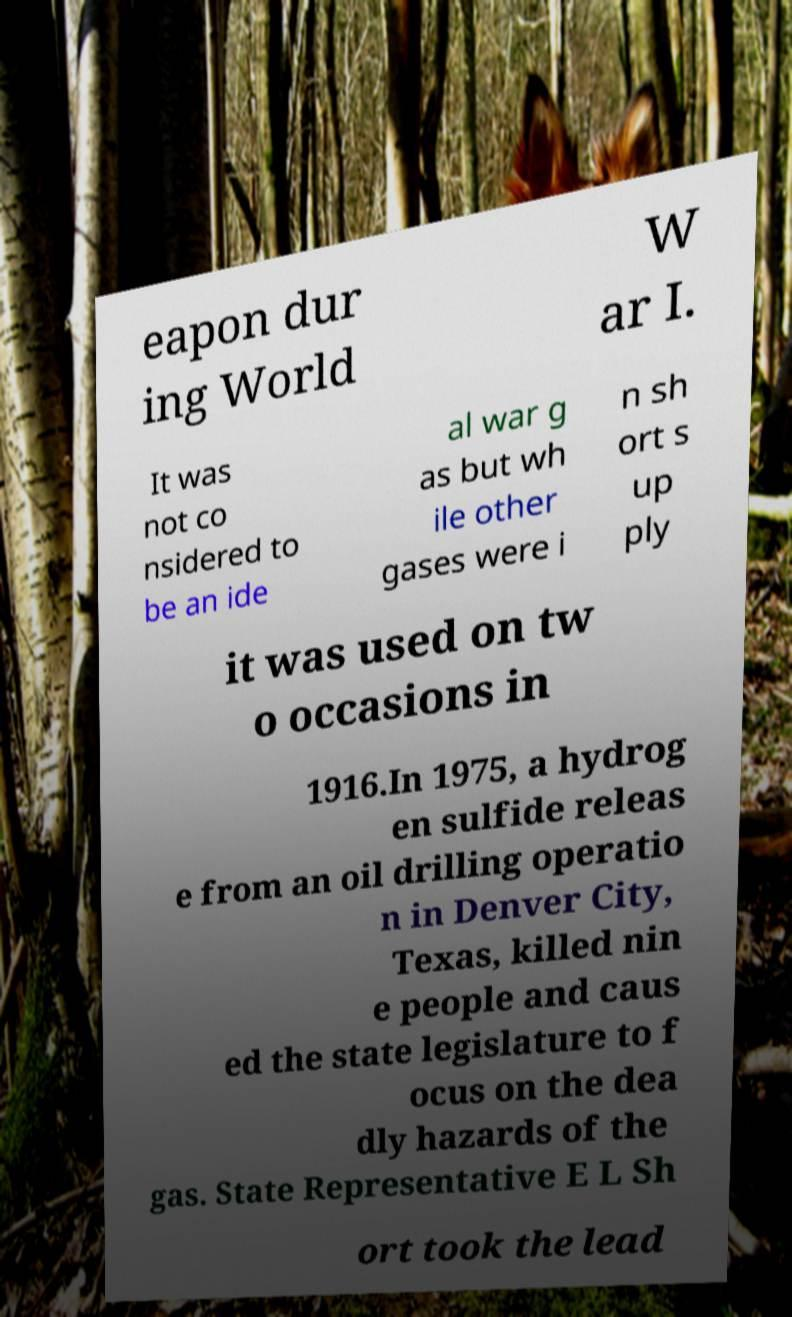Could you assist in decoding the text presented in this image and type it out clearly? eapon dur ing World W ar I. It was not co nsidered to be an ide al war g as but wh ile other gases were i n sh ort s up ply it was used on tw o occasions in 1916.In 1975, a hydrog en sulfide releas e from an oil drilling operatio n in Denver City, Texas, killed nin e people and caus ed the state legislature to f ocus on the dea dly hazards of the gas. State Representative E L Sh ort took the lead 